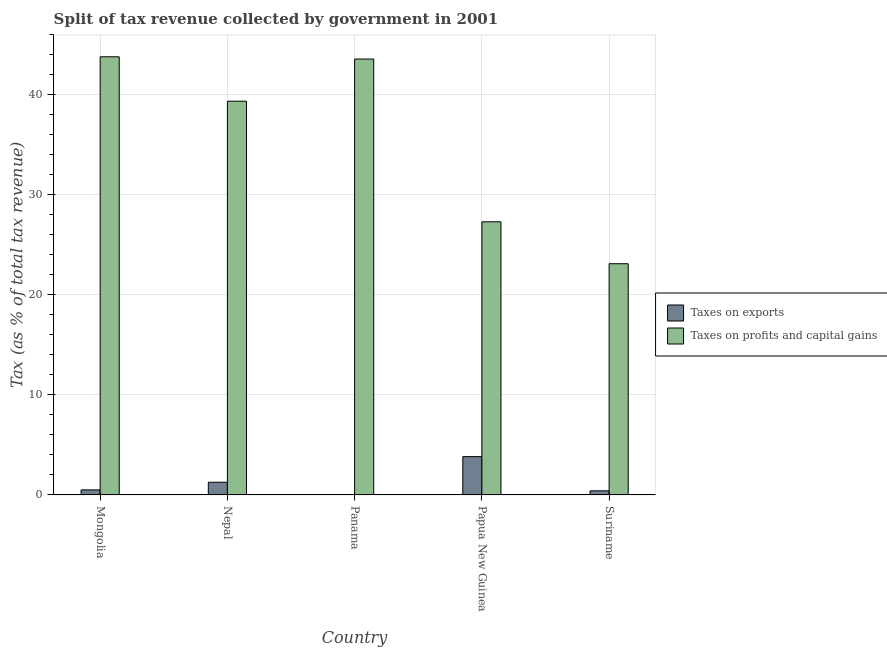How many bars are there on the 2nd tick from the left?
Make the answer very short. 2. How many bars are there on the 1st tick from the right?
Your response must be concise. 2. What is the label of the 3rd group of bars from the left?
Your answer should be very brief. Panama. What is the percentage of revenue obtained from taxes on profits and capital gains in Suriname?
Your answer should be compact. 23.12. Across all countries, what is the maximum percentage of revenue obtained from taxes on exports?
Your answer should be very brief. 3.83. Across all countries, what is the minimum percentage of revenue obtained from taxes on exports?
Provide a succinct answer. 0. In which country was the percentage of revenue obtained from taxes on exports maximum?
Your answer should be very brief. Papua New Guinea. In which country was the percentage of revenue obtained from taxes on exports minimum?
Provide a succinct answer. Panama. What is the total percentage of revenue obtained from taxes on profits and capital gains in the graph?
Provide a short and direct response. 177.24. What is the difference between the percentage of revenue obtained from taxes on exports in Mongolia and that in Nepal?
Your response must be concise. -0.77. What is the difference between the percentage of revenue obtained from taxes on profits and capital gains in Suriname and the percentage of revenue obtained from taxes on exports in Panama?
Your response must be concise. 23.12. What is the average percentage of revenue obtained from taxes on profits and capital gains per country?
Keep it short and to the point. 35.45. What is the difference between the percentage of revenue obtained from taxes on profits and capital gains and percentage of revenue obtained from taxes on exports in Panama?
Your answer should be compact. 43.59. In how many countries, is the percentage of revenue obtained from taxes on profits and capital gains greater than 36 %?
Provide a succinct answer. 3. What is the ratio of the percentage of revenue obtained from taxes on profits and capital gains in Nepal to that in Panama?
Give a very brief answer. 0.9. Is the percentage of revenue obtained from taxes on exports in Panama less than that in Papua New Guinea?
Provide a short and direct response. Yes. What is the difference between the highest and the second highest percentage of revenue obtained from taxes on exports?
Provide a succinct answer. 2.56. What is the difference between the highest and the lowest percentage of revenue obtained from taxes on profits and capital gains?
Provide a short and direct response. 20.7. In how many countries, is the percentage of revenue obtained from taxes on exports greater than the average percentage of revenue obtained from taxes on exports taken over all countries?
Your response must be concise. 2. Is the sum of the percentage of revenue obtained from taxes on profits and capital gains in Panama and Suriname greater than the maximum percentage of revenue obtained from taxes on exports across all countries?
Your answer should be compact. Yes. What does the 2nd bar from the left in Nepal represents?
Provide a short and direct response. Taxes on profits and capital gains. What does the 2nd bar from the right in Panama represents?
Your answer should be compact. Taxes on exports. Are all the bars in the graph horizontal?
Provide a short and direct response. No. How many countries are there in the graph?
Your response must be concise. 5. Does the graph contain grids?
Keep it short and to the point. Yes. Where does the legend appear in the graph?
Provide a succinct answer. Center right. How many legend labels are there?
Keep it short and to the point. 2. How are the legend labels stacked?
Provide a short and direct response. Vertical. What is the title of the graph?
Ensure brevity in your answer.  Split of tax revenue collected by government in 2001. What is the label or title of the X-axis?
Offer a terse response. Country. What is the label or title of the Y-axis?
Give a very brief answer. Tax (as % of total tax revenue). What is the Tax (as % of total tax revenue) in Taxes on exports in Mongolia?
Your response must be concise. 0.5. What is the Tax (as % of total tax revenue) in Taxes on profits and capital gains in Mongolia?
Your answer should be compact. 43.82. What is the Tax (as % of total tax revenue) of Taxes on exports in Nepal?
Ensure brevity in your answer.  1.27. What is the Tax (as % of total tax revenue) of Taxes on profits and capital gains in Nepal?
Ensure brevity in your answer.  39.38. What is the Tax (as % of total tax revenue) of Taxes on exports in Panama?
Provide a succinct answer. 0. What is the Tax (as % of total tax revenue) of Taxes on profits and capital gains in Panama?
Give a very brief answer. 43.6. What is the Tax (as % of total tax revenue) of Taxes on exports in Papua New Guinea?
Provide a succinct answer. 3.83. What is the Tax (as % of total tax revenue) in Taxes on profits and capital gains in Papua New Guinea?
Offer a very short reply. 27.32. What is the Tax (as % of total tax revenue) of Taxes on exports in Suriname?
Your answer should be very brief. 0.41. What is the Tax (as % of total tax revenue) in Taxes on profits and capital gains in Suriname?
Keep it short and to the point. 23.12. Across all countries, what is the maximum Tax (as % of total tax revenue) of Taxes on exports?
Your answer should be very brief. 3.83. Across all countries, what is the maximum Tax (as % of total tax revenue) of Taxes on profits and capital gains?
Your answer should be very brief. 43.82. Across all countries, what is the minimum Tax (as % of total tax revenue) in Taxes on exports?
Offer a terse response. 0. Across all countries, what is the minimum Tax (as % of total tax revenue) in Taxes on profits and capital gains?
Your response must be concise. 23.12. What is the total Tax (as % of total tax revenue) in Taxes on exports in the graph?
Provide a short and direct response. 6.02. What is the total Tax (as % of total tax revenue) in Taxes on profits and capital gains in the graph?
Your answer should be compact. 177.24. What is the difference between the Tax (as % of total tax revenue) of Taxes on exports in Mongolia and that in Nepal?
Offer a terse response. -0.77. What is the difference between the Tax (as % of total tax revenue) of Taxes on profits and capital gains in Mongolia and that in Nepal?
Provide a short and direct response. 4.44. What is the difference between the Tax (as % of total tax revenue) of Taxes on exports in Mongolia and that in Panama?
Give a very brief answer. 0.5. What is the difference between the Tax (as % of total tax revenue) of Taxes on profits and capital gains in Mongolia and that in Panama?
Provide a succinct answer. 0.23. What is the difference between the Tax (as % of total tax revenue) of Taxes on exports in Mongolia and that in Papua New Guinea?
Provide a short and direct response. -3.33. What is the difference between the Tax (as % of total tax revenue) of Taxes on profits and capital gains in Mongolia and that in Papua New Guinea?
Your answer should be compact. 16.5. What is the difference between the Tax (as % of total tax revenue) of Taxes on exports in Mongolia and that in Suriname?
Offer a very short reply. 0.09. What is the difference between the Tax (as % of total tax revenue) of Taxes on profits and capital gains in Mongolia and that in Suriname?
Keep it short and to the point. 20.7. What is the difference between the Tax (as % of total tax revenue) in Taxes on exports in Nepal and that in Panama?
Your response must be concise. 1.26. What is the difference between the Tax (as % of total tax revenue) in Taxes on profits and capital gains in Nepal and that in Panama?
Make the answer very short. -4.22. What is the difference between the Tax (as % of total tax revenue) in Taxes on exports in Nepal and that in Papua New Guinea?
Your answer should be compact. -2.56. What is the difference between the Tax (as % of total tax revenue) in Taxes on profits and capital gains in Nepal and that in Papua New Guinea?
Your answer should be very brief. 12.06. What is the difference between the Tax (as % of total tax revenue) in Taxes on exports in Nepal and that in Suriname?
Keep it short and to the point. 0.86. What is the difference between the Tax (as % of total tax revenue) of Taxes on profits and capital gains in Nepal and that in Suriname?
Your response must be concise. 16.26. What is the difference between the Tax (as % of total tax revenue) in Taxes on exports in Panama and that in Papua New Guinea?
Make the answer very short. -3.83. What is the difference between the Tax (as % of total tax revenue) in Taxes on profits and capital gains in Panama and that in Papua New Guinea?
Your answer should be very brief. 16.28. What is the difference between the Tax (as % of total tax revenue) of Taxes on exports in Panama and that in Suriname?
Your answer should be compact. -0.41. What is the difference between the Tax (as % of total tax revenue) of Taxes on profits and capital gains in Panama and that in Suriname?
Ensure brevity in your answer.  20.47. What is the difference between the Tax (as % of total tax revenue) of Taxes on exports in Papua New Guinea and that in Suriname?
Ensure brevity in your answer.  3.42. What is the difference between the Tax (as % of total tax revenue) in Taxes on profits and capital gains in Papua New Guinea and that in Suriname?
Your answer should be very brief. 4.19. What is the difference between the Tax (as % of total tax revenue) in Taxes on exports in Mongolia and the Tax (as % of total tax revenue) in Taxes on profits and capital gains in Nepal?
Your answer should be very brief. -38.88. What is the difference between the Tax (as % of total tax revenue) in Taxes on exports in Mongolia and the Tax (as % of total tax revenue) in Taxes on profits and capital gains in Panama?
Make the answer very short. -43.09. What is the difference between the Tax (as % of total tax revenue) of Taxes on exports in Mongolia and the Tax (as % of total tax revenue) of Taxes on profits and capital gains in Papua New Guinea?
Your response must be concise. -26.81. What is the difference between the Tax (as % of total tax revenue) in Taxes on exports in Mongolia and the Tax (as % of total tax revenue) in Taxes on profits and capital gains in Suriname?
Your response must be concise. -22.62. What is the difference between the Tax (as % of total tax revenue) in Taxes on exports in Nepal and the Tax (as % of total tax revenue) in Taxes on profits and capital gains in Panama?
Give a very brief answer. -42.33. What is the difference between the Tax (as % of total tax revenue) in Taxes on exports in Nepal and the Tax (as % of total tax revenue) in Taxes on profits and capital gains in Papua New Guinea?
Your answer should be very brief. -26.05. What is the difference between the Tax (as % of total tax revenue) of Taxes on exports in Nepal and the Tax (as % of total tax revenue) of Taxes on profits and capital gains in Suriname?
Provide a short and direct response. -21.85. What is the difference between the Tax (as % of total tax revenue) of Taxes on exports in Panama and the Tax (as % of total tax revenue) of Taxes on profits and capital gains in Papua New Guinea?
Offer a terse response. -27.31. What is the difference between the Tax (as % of total tax revenue) in Taxes on exports in Panama and the Tax (as % of total tax revenue) in Taxes on profits and capital gains in Suriname?
Give a very brief answer. -23.12. What is the difference between the Tax (as % of total tax revenue) of Taxes on exports in Papua New Guinea and the Tax (as % of total tax revenue) of Taxes on profits and capital gains in Suriname?
Your response must be concise. -19.29. What is the average Tax (as % of total tax revenue) in Taxes on exports per country?
Your response must be concise. 1.2. What is the average Tax (as % of total tax revenue) in Taxes on profits and capital gains per country?
Make the answer very short. 35.45. What is the difference between the Tax (as % of total tax revenue) in Taxes on exports and Tax (as % of total tax revenue) in Taxes on profits and capital gains in Mongolia?
Your answer should be very brief. -43.32. What is the difference between the Tax (as % of total tax revenue) of Taxes on exports and Tax (as % of total tax revenue) of Taxes on profits and capital gains in Nepal?
Your response must be concise. -38.11. What is the difference between the Tax (as % of total tax revenue) of Taxes on exports and Tax (as % of total tax revenue) of Taxes on profits and capital gains in Panama?
Provide a short and direct response. -43.59. What is the difference between the Tax (as % of total tax revenue) in Taxes on exports and Tax (as % of total tax revenue) in Taxes on profits and capital gains in Papua New Guinea?
Your answer should be very brief. -23.49. What is the difference between the Tax (as % of total tax revenue) of Taxes on exports and Tax (as % of total tax revenue) of Taxes on profits and capital gains in Suriname?
Give a very brief answer. -22.71. What is the ratio of the Tax (as % of total tax revenue) of Taxes on exports in Mongolia to that in Nepal?
Give a very brief answer. 0.4. What is the ratio of the Tax (as % of total tax revenue) of Taxes on profits and capital gains in Mongolia to that in Nepal?
Offer a terse response. 1.11. What is the ratio of the Tax (as % of total tax revenue) of Taxes on exports in Mongolia to that in Panama?
Provide a succinct answer. 137.56. What is the ratio of the Tax (as % of total tax revenue) of Taxes on profits and capital gains in Mongolia to that in Panama?
Give a very brief answer. 1.01. What is the ratio of the Tax (as % of total tax revenue) of Taxes on exports in Mongolia to that in Papua New Guinea?
Your answer should be compact. 0.13. What is the ratio of the Tax (as % of total tax revenue) of Taxes on profits and capital gains in Mongolia to that in Papua New Guinea?
Make the answer very short. 1.6. What is the ratio of the Tax (as % of total tax revenue) in Taxes on exports in Mongolia to that in Suriname?
Provide a succinct answer. 1.23. What is the ratio of the Tax (as % of total tax revenue) in Taxes on profits and capital gains in Mongolia to that in Suriname?
Offer a terse response. 1.9. What is the ratio of the Tax (as % of total tax revenue) of Taxes on exports in Nepal to that in Panama?
Ensure brevity in your answer.  346.74. What is the ratio of the Tax (as % of total tax revenue) of Taxes on profits and capital gains in Nepal to that in Panama?
Your answer should be compact. 0.9. What is the ratio of the Tax (as % of total tax revenue) in Taxes on exports in Nepal to that in Papua New Guinea?
Keep it short and to the point. 0.33. What is the ratio of the Tax (as % of total tax revenue) in Taxes on profits and capital gains in Nepal to that in Papua New Guinea?
Offer a very short reply. 1.44. What is the ratio of the Tax (as % of total tax revenue) in Taxes on exports in Nepal to that in Suriname?
Offer a terse response. 3.09. What is the ratio of the Tax (as % of total tax revenue) in Taxes on profits and capital gains in Nepal to that in Suriname?
Your answer should be compact. 1.7. What is the ratio of the Tax (as % of total tax revenue) of Taxes on exports in Panama to that in Papua New Guinea?
Your answer should be very brief. 0. What is the ratio of the Tax (as % of total tax revenue) in Taxes on profits and capital gains in Panama to that in Papua New Guinea?
Your answer should be very brief. 1.6. What is the ratio of the Tax (as % of total tax revenue) of Taxes on exports in Panama to that in Suriname?
Your answer should be very brief. 0.01. What is the ratio of the Tax (as % of total tax revenue) of Taxes on profits and capital gains in Panama to that in Suriname?
Your answer should be compact. 1.89. What is the ratio of the Tax (as % of total tax revenue) in Taxes on exports in Papua New Guinea to that in Suriname?
Keep it short and to the point. 9.34. What is the ratio of the Tax (as % of total tax revenue) in Taxes on profits and capital gains in Papua New Guinea to that in Suriname?
Make the answer very short. 1.18. What is the difference between the highest and the second highest Tax (as % of total tax revenue) in Taxes on exports?
Offer a very short reply. 2.56. What is the difference between the highest and the second highest Tax (as % of total tax revenue) in Taxes on profits and capital gains?
Your response must be concise. 0.23. What is the difference between the highest and the lowest Tax (as % of total tax revenue) of Taxes on exports?
Keep it short and to the point. 3.83. What is the difference between the highest and the lowest Tax (as % of total tax revenue) of Taxes on profits and capital gains?
Keep it short and to the point. 20.7. 